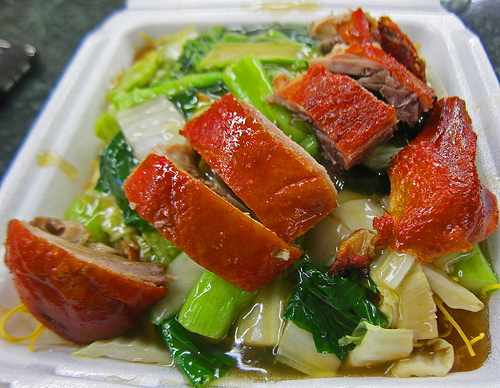<image>
Is there a bok choy under the pork? Yes. The bok choy is positioned underneath the pork, with the pork above it in the vertical space. 